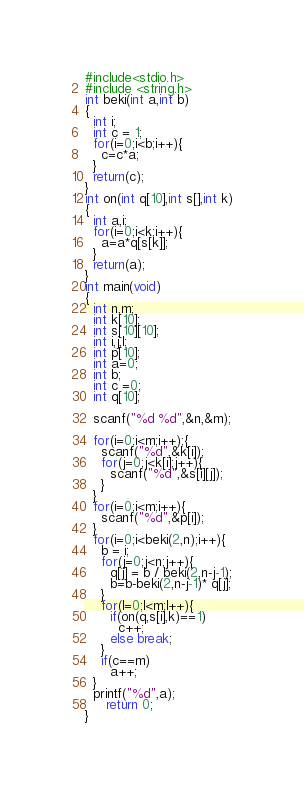Convert code to text. <code><loc_0><loc_0><loc_500><loc_500><_C_>#include<stdio.h>
#include <string.h>
int beki(int a,int b)
{
  int i;
  int c = 1;
  for(i=0;i<b;i++){
    c=c*a;
  }
  return(c);
}
int on(int q[10],int s[],int k)
{
  int a,i;
  for(i=0;i<k;i++){
    a=a*q[s[k]];
  }
  return(a);
}
int main(void)
{
  int n,m;
  int k[10];
  int s[10][10];
  int i,j,l;
  int p[10];
  int a=0;
  int b;
  int c =0;
  int q[10];
  
  scanf("%d %d",&n,&m);
  
  for(i=0;i<m;i++);{
    scanf("%d",&k[i]);
    for(j=0;j<k[i];j++){
      scanf("%d",&s[i][j]);
    }
  }
  for(i=0;i<m;i++){
    scanf("%d",&p[i]);
  }
  for(i=0;i<beki(2,n);i++){
    b = i;
    for(j=0;j<n;j++){
      q[j] = b / beki(2,n-j-1);
      b=b-beki(2,n-j-1)* q[j];
    }
    for(l=0;l<m;l++){
      if(on(q,s[i],k)==1)
        c++;
      else break;
    }
    if(c==m)
      a++;
  }
  printf("%d",a);
     return 0;
}</code> 